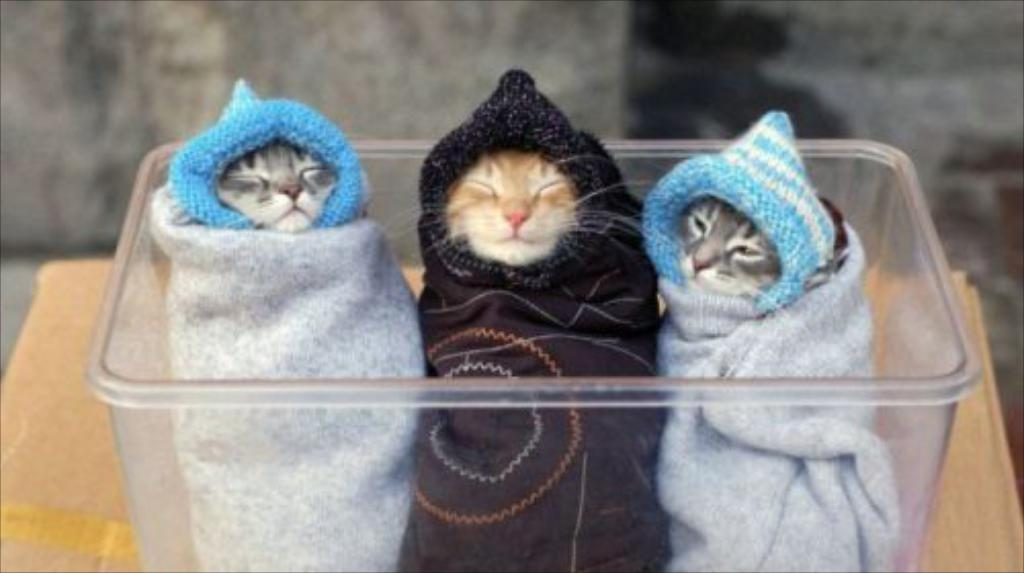How many kittens are in the container in the image? There are three kittens in the container in the image. Where is the container located in the image? The container is at the bottom of the image. What is the container placed on in the image? The container is kept on a surface in the image. What can be seen in the background of the image? There appears to be a wall in the background of the image. How does the beef help the kittens in the image? There is no beef present in the image, so it cannot help the kittens. 